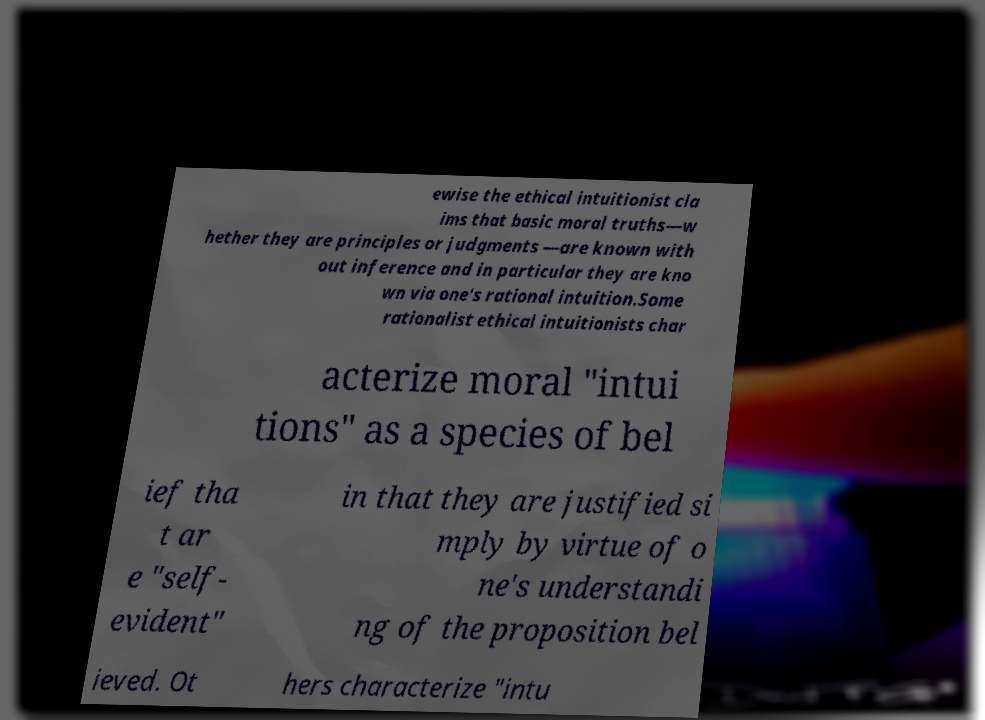Please identify and transcribe the text found in this image. ewise the ethical intuitionist cla ims that basic moral truths—w hether they are principles or judgments —are known with out inference and in particular they are kno wn via one's rational intuition.Some rationalist ethical intuitionists char acterize moral "intui tions" as a species of bel ief tha t ar e "self- evident" in that they are justified si mply by virtue of o ne's understandi ng of the proposition bel ieved. Ot hers characterize "intu 